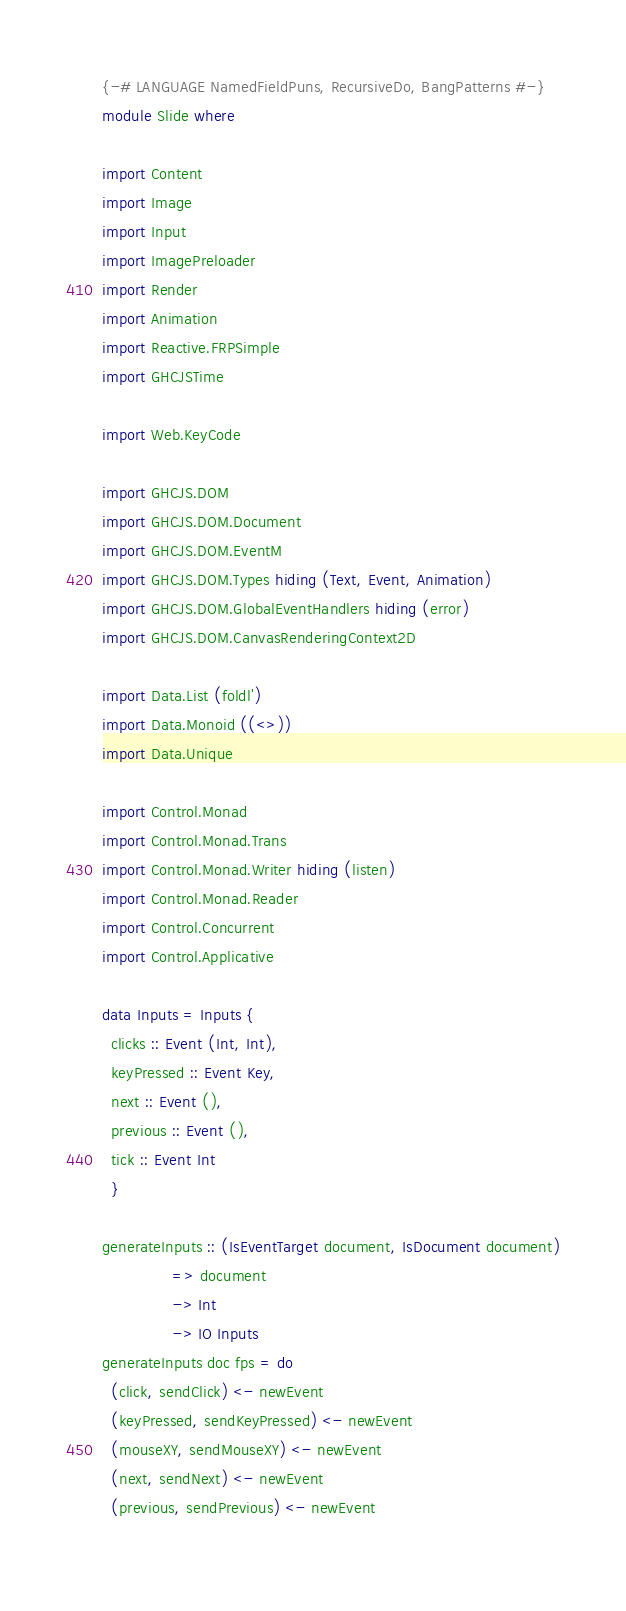<code> <loc_0><loc_0><loc_500><loc_500><_Haskell_>{-# LANGUAGE NamedFieldPuns, RecursiveDo, BangPatterns #-}
module Slide where

import Content
import Image
import Input
import ImagePreloader
import Render
import Animation
import Reactive.FRPSimple
import GHCJSTime

import Web.KeyCode

import GHCJS.DOM
import GHCJS.DOM.Document
import GHCJS.DOM.EventM
import GHCJS.DOM.Types hiding (Text, Event, Animation)
import GHCJS.DOM.GlobalEventHandlers hiding (error)
import GHCJS.DOM.CanvasRenderingContext2D

import Data.List (foldl')
import Data.Monoid ((<>))
import Data.Unique
  
import Control.Monad
import Control.Monad.Trans
import Control.Monad.Writer hiding (listen)
import Control.Monad.Reader 
import Control.Concurrent
import Control.Applicative

data Inputs = Inputs {
  clicks :: Event (Int, Int),
  keyPressed :: Event Key,
  next :: Event (),
  previous :: Event (),
  tick :: Event Int
  }

generateInputs :: (IsEventTarget document, IsDocument document)
               => document
               -> Int
               -> IO Inputs
generateInputs doc fps = do
  (click, sendClick) <- newEvent
  (keyPressed, sendKeyPressed) <- newEvent
  (mouseXY, sendMouseXY) <- newEvent
  (next, sendNext) <- newEvent
  (previous, sendPrevious) <- newEvent
  </code> 